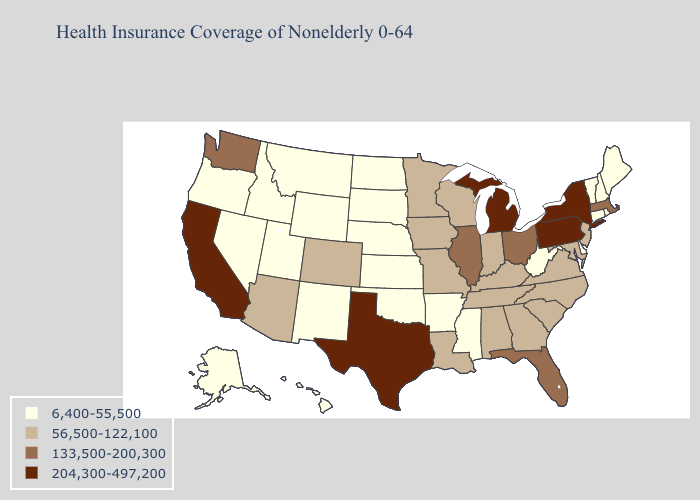Among the states that border Texas , which have the lowest value?
Quick response, please. Arkansas, New Mexico, Oklahoma. What is the lowest value in states that border Ohio?
Give a very brief answer. 6,400-55,500. Does Tennessee have a lower value than Arizona?
Concise answer only. No. Name the states that have a value in the range 133,500-200,300?
Keep it brief. Florida, Illinois, Massachusetts, Ohio, Washington. Does Illinois have the same value as New Jersey?
Keep it brief. No. Name the states that have a value in the range 56,500-122,100?
Short answer required. Alabama, Arizona, Colorado, Georgia, Indiana, Iowa, Kentucky, Louisiana, Maryland, Minnesota, Missouri, New Jersey, North Carolina, South Carolina, Tennessee, Virginia, Wisconsin. Does New Jersey have the highest value in the USA?
Answer briefly. No. Which states hav the highest value in the West?
Be succinct. California. Does Texas have the highest value in the South?
Concise answer only. Yes. Which states have the highest value in the USA?
Write a very short answer. California, Michigan, New York, Pennsylvania, Texas. Among the states that border Vermont , does New York have the highest value?
Be succinct. Yes. Name the states that have a value in the range 56,500-122,100?
Write a very short answer. Alabama, Arizona, Colorado, Georgia, Indiana, Iowa, Kentucky, Louisiana, Maryland, Minnesota, Missouri, New Jersey, North Carolina, South Carolina, Tennessee, Virginia, Wisconsin. Name the states that have a value in the range 133,500-200,300?
Keep it brief. Florida, Illinois, Massachusetts, Ohio, Washington. Name the states that have a value in the range 56,500-122,100?
Give a very brief answer. Alabama, Arizona, Colorado, Georgia, Indiana, Iowa, Kentucky, Louisiana, Maryland, Minnesota, Missouri, New Jersey, North Carolina, South Carolina, Tennessee, Virginia, Wisconsin. What is the value of Texas?
Keep it brief. 204,300-497,200. 